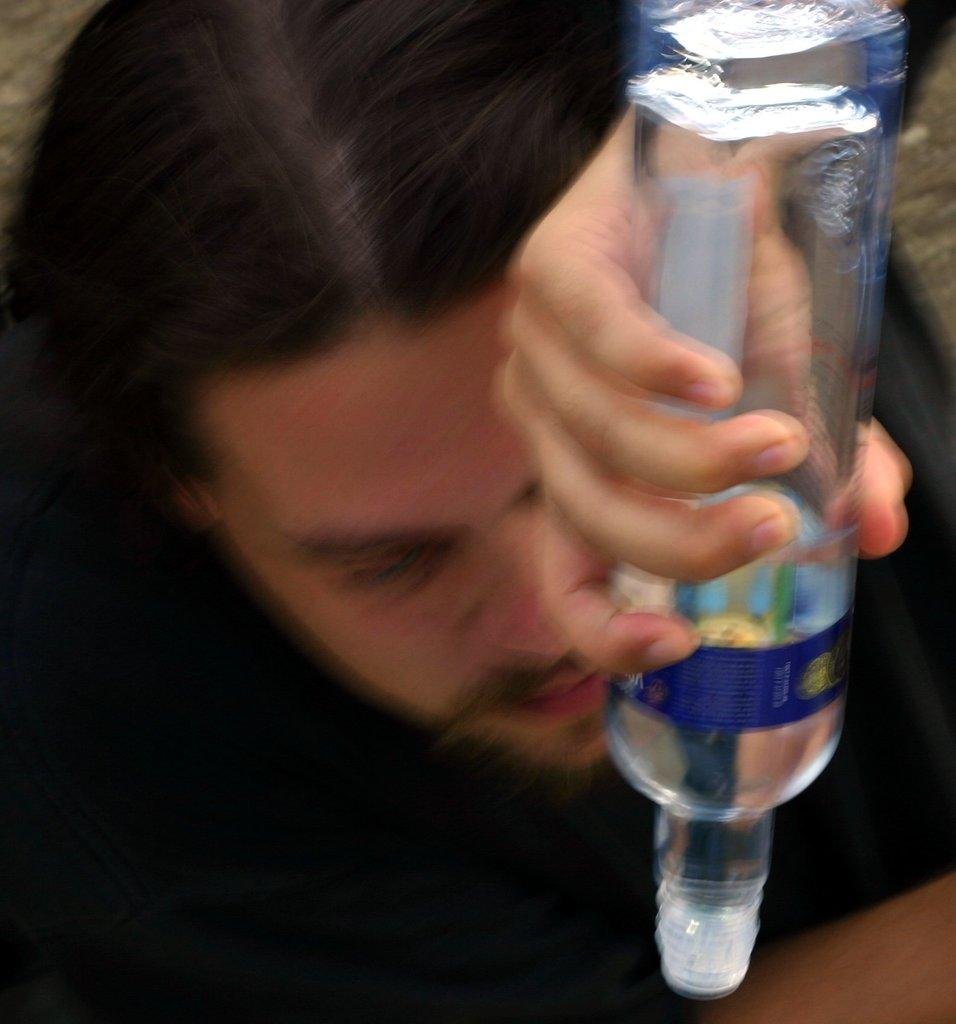What is the main subject of the image? There is a man in the image. What is the man holding in his hand? The man is holding a bottle in his hand. What type of jeans is the animal wearing in the image? There is no animal present in the image, and therefore no jeans or any other clothing can be observed. 